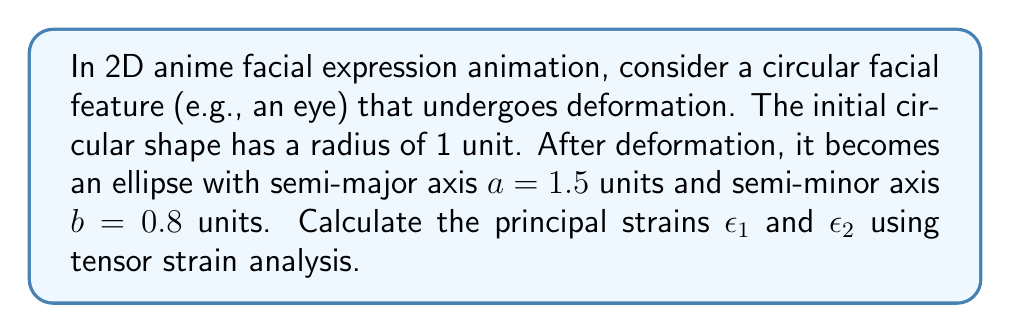Show me your answer to this math problem. To solve this problem, we'll follow these steps:

1) In 2D tensor strain analysis, principal strains represent the maximum and minimum stretching or compression in the deformed object.

2) For a circular object deforming into an ellipse, the principal strains are given by:

   $$\epsilon_1 = \ln(a)$$
   $$\epsilon_2 = \ln(b)$$

   Where $a$ is the semi-major axis and $b$ is the semi-minor axis of the resulting ellipse.

3) Given:
   - Initial radius = 1 unit
   - Semi-major axis $a = 1.5$ units
   - Semi-minor axis $b = 0.8$ units

4) Calculate $\epsilon_1$:
   $$\epsilon_1 = \ln(1.5) \approx 0.4055$$

5) Calculate $\epsilon_2$:
   $$\epsilon_2 = \ln(0.8) \approx -0.2231$$

6) The positive value of $\epsilon_1$ indicates stretching along the major axis, while the negative value of $\epsilon_2$ indicates compression along the minor axis.

These principal strains can be used to model and animate the deformation of 2D anime facial features, helping to create more expressive and dynamic character expressions.
Answer: $\epsilon_1 \approx 0.4055$, $\epsilon_2 \approx -0.2231$ 